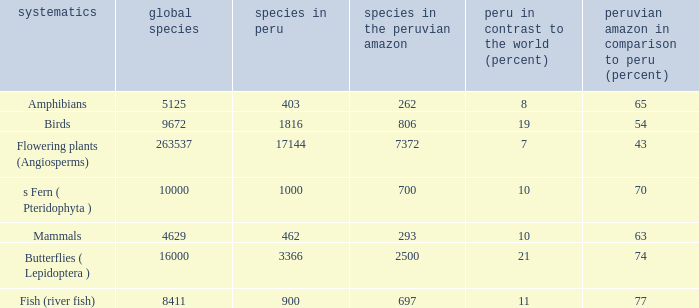What's the maximum peru vs. world (percent) with 9672 species in the world  19.0. 